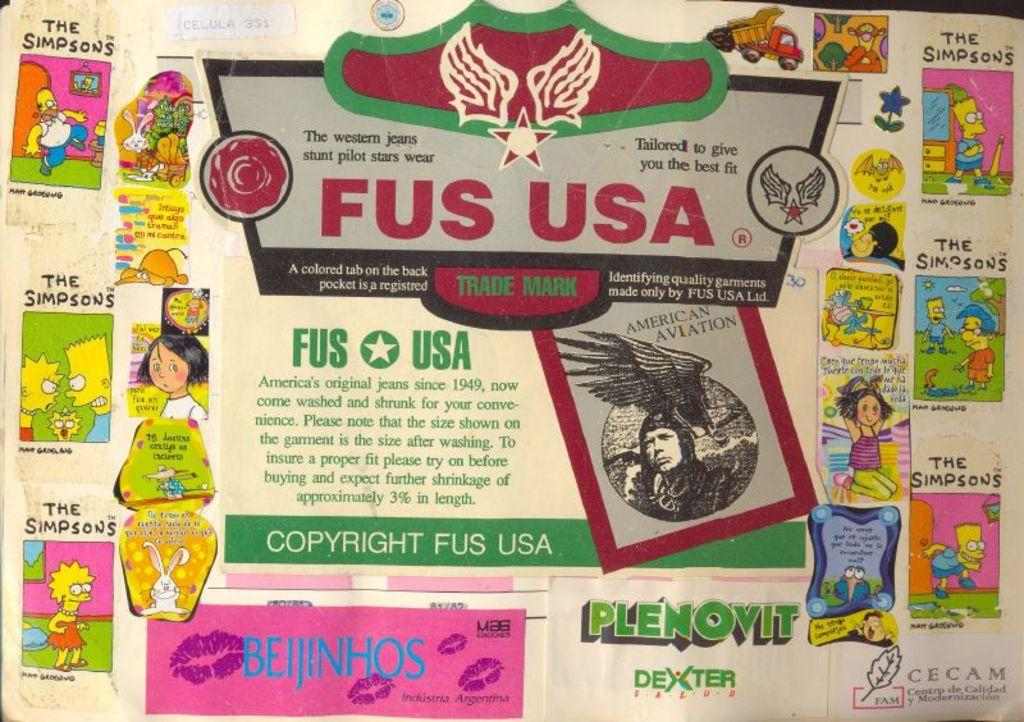What is present in the image that features conversations? The image contains a poster with animated conversations. What can be found in the middle of the poster? There is some information in the middle of the poster. What type of bells can be seen hanging from the poster in the image? There are no bells present on the poster in the image. 